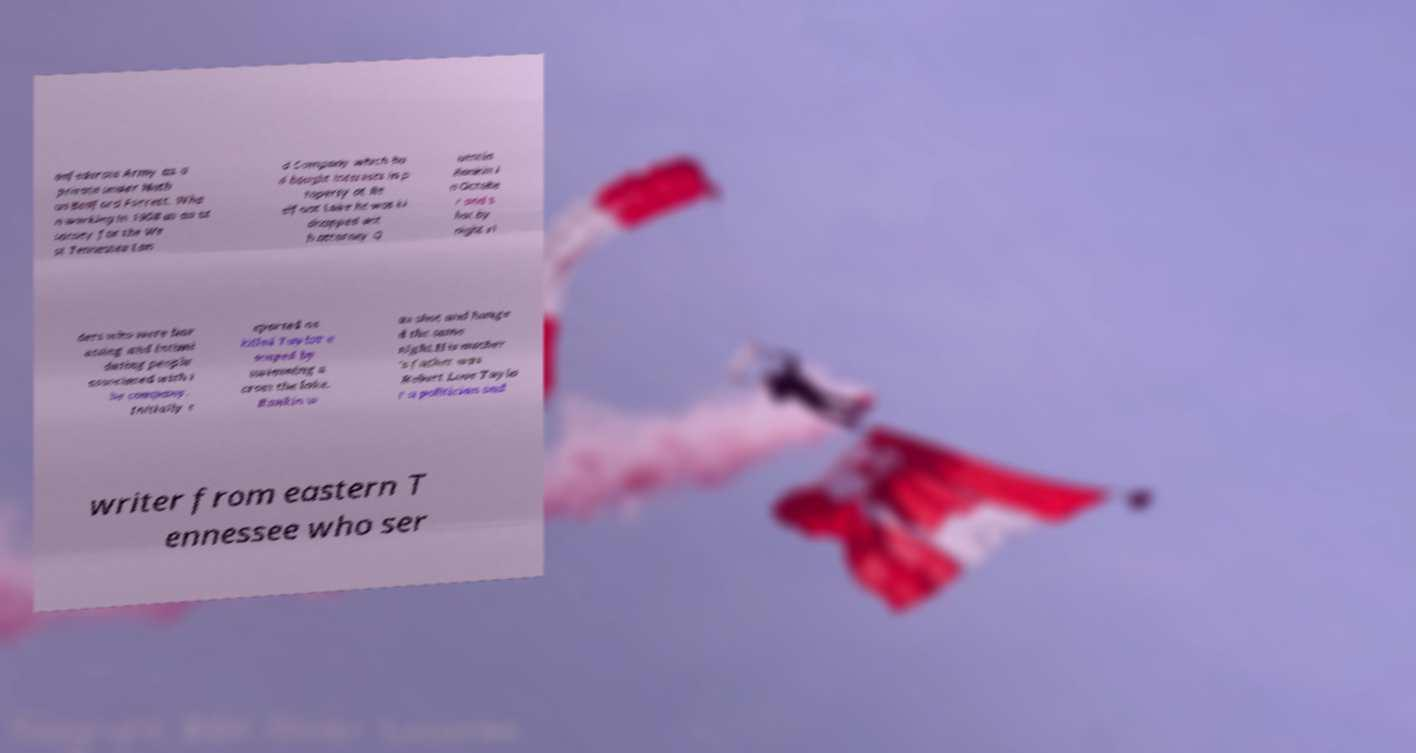Could you extract and type out the text from this image? onfederate Army as a private under Nath an Bedford Forrest. Whe n working in 1908 as an at torney for the We st Tennessee Lan d Company which ha d bought interests in p roperty at Re elfoot Lake he was ki dnapped wit h attorney Q uentin Rankin i n Octobe r and s hot by night ri ders who were har assing and intimi dating people associated with t he company. Initially r eported as killed Taylor e scaped by swimming a cross the lake. Rankin w as shot and hange d the same night.His mother 's father was Robert Love Taylo r a politician and writer from eastern T ennessee who ser 